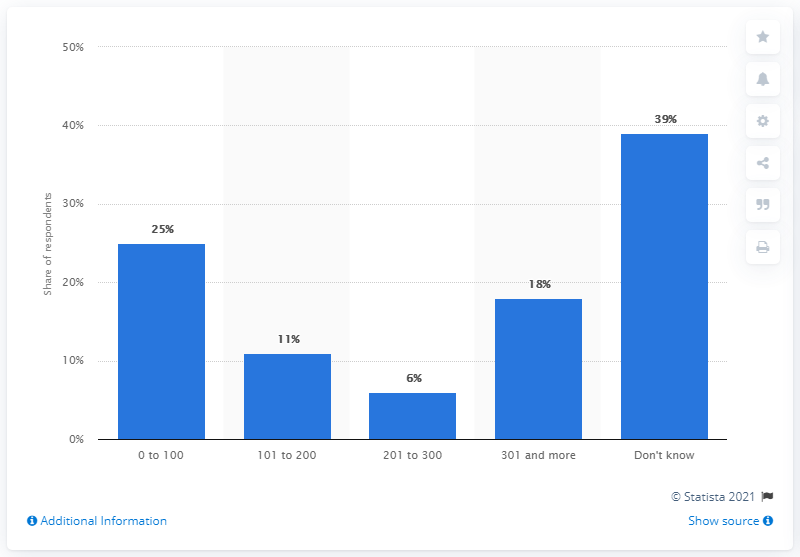Outline some significant characteristics in this image. In March 2015, 11% of respondents had 101 to 200 followers on Instagram. 